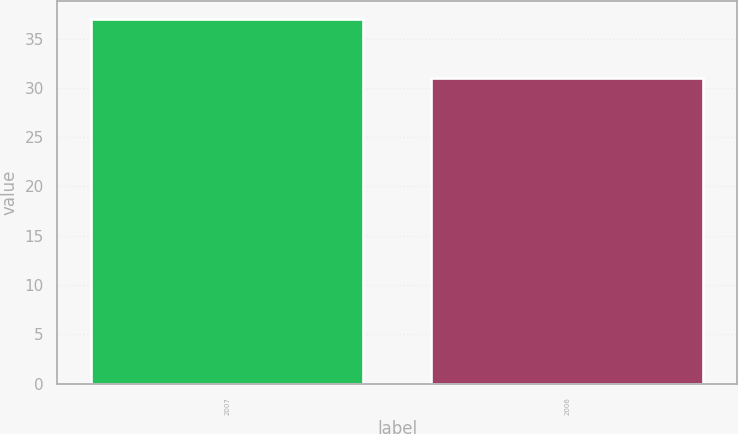<chart> <loc_0><loc_0><loc_500><loc_500><bar_chart><fcel>2007<fcel>2006<nl><fcel>37<fcel>31<nl></chart> 